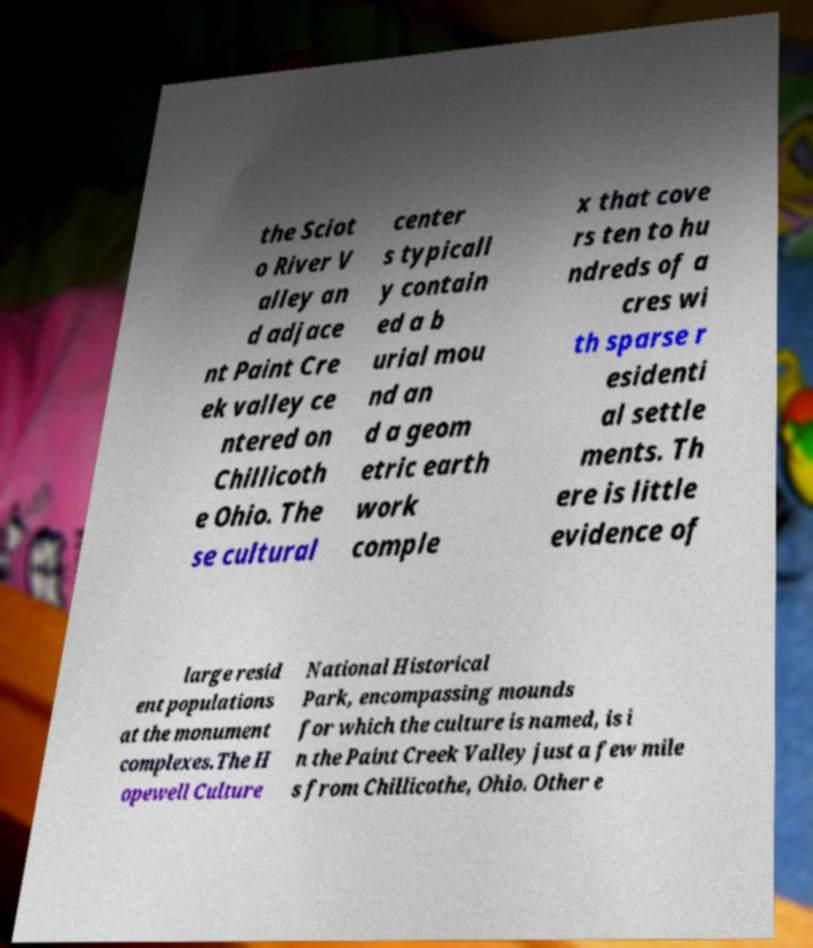Could you extract and type out the text from this image? the Sciot o River V alley an d adjace nt Paint Cre ek valley ce ntered on Chillicoth e Ohio. The se cultural center s typicall y contain ed a b urial mou nd an d a geom etric earth work comple x that cove rs ten to hu ndreds of a cres wi th sparse r esidenti al settle ments. Th ere is little evidence of large resid ent populations at the monument complexes.The H opewell Culture National Historical Park, encompassing mounds for which the culture is named, is i n the Paint Creek Valley just a few mile s from Chillicothe, Ohio. Other e 